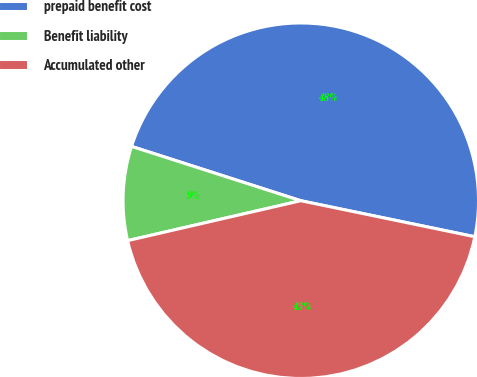<chart> <loc_0><loc_0><loc_500><loc_500><pie_chart><fcel>prepaid benefit cost<fcel>Benefit liability<fcel>Accumulated other<nl><fcel>48.31%<fcel>8.55%<fcel>43.15%<nl></chart> 